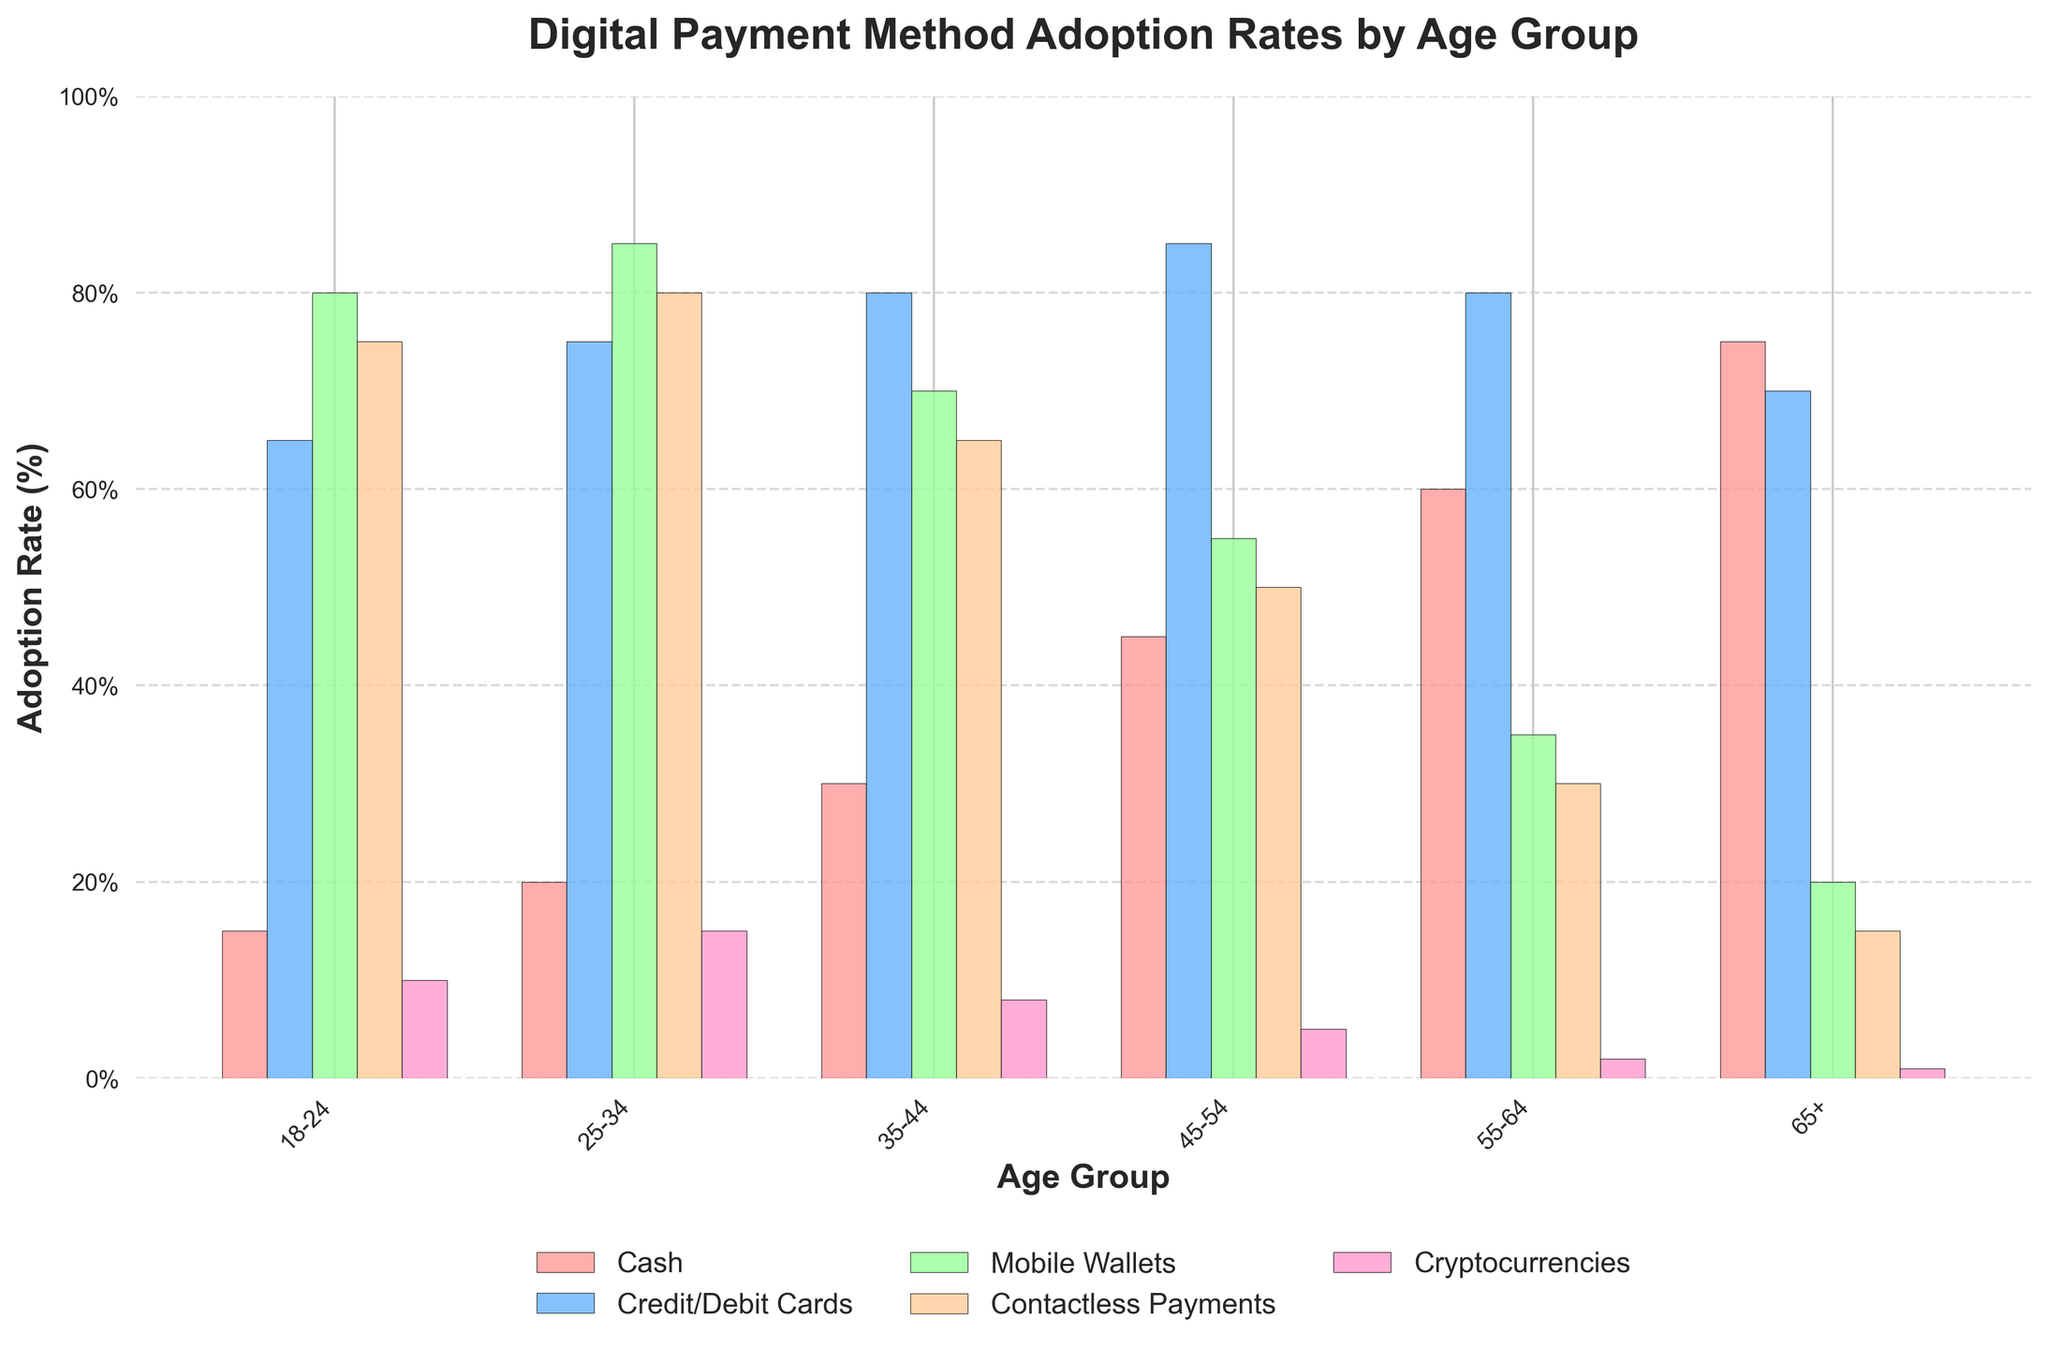What age group shows the highest adoption rate for Mobile Wallets? From the chart, look for the bar corresponding to Mobile Wallets and see which age group it reaches the highest percentage. The highest bar for Mobile Wallets is in the 25-34 age group, hitting 85%.
Answer: 25-34 Which payment method is least adopted by the 65+ age group? Identify the lowest adoption rate among the bars representing different payment methods for the 65+ age group. The lowest is Cryptocurrencies, at 1%.
Answer: Cryptocurrencies Compare the adoption rates of Contactless Payments between the 18-24 and 45-54 age groups; which one is higher and by how much? Observe the height of the bars representing Contactless Payments for the 18-24 and 45-54 age groups. The rates are 75% and 50% respectively. So, 75% - 50% = 25%. 18-24 has a 25% higher adoption rate.
Answer: 18-24 by 25% What is the average adoption rate of Credit/Debit Cards across all age groups? Add up all the percentages for Credit/Debit Cards (65%, 75%, 80%, 85%, 80%, 70%) and divide by the number of age groups, which is 6. This gives (65+75+80+85+80+70)/6 = 75.8%.
Answer: 75.8% Is the rate of Cash adoption higher for the 55-64 age group or the 18-24 age group, and by how much? Examine the heights of the bars for Cash in the age groups 55-64 and 18-24. Rates are 60% and 15% respectively. Thus, 60% - 15% = 45%. The 55-64 age group has a 45% higher cash adoption rate.
Answer: 55-64 by 45% Which age group has the lowest adoption rate of Contactless Payments, and what is the percentage? Identify the shortest bar corresponding to Contactless Payments. The 65+ group has the lowest percentage at 15%.
Answer: 65+ at 15% Sum the adoption rates of Cryptocurrencies in the 18-24 and 25-34 age groups. What is the total percentage? Add the percentages for Cryptocurrencies from the 18-24 (10%) and 25-34 (15%) age groups, resulting in 10% + 15% = 25%.
Answer: 25% For the age group 35-44, which payment method shows the second highest adoption rate and what is it? Observe the bars for different payment methods in the 35-44 age group. The highest adoption rate is for Credit/Debit Cards at 80%, and the second highest is Cash at 70%.
Answer: Cash at 70% What is the difference in the adoption rates of Mobile Wallets between the 25-34 and 45-54 age groups? Compare the bars representing Mobile Wallets in the 25-34 and 45-54 age groups. The rates are 85% and 55%, respectively. Thus, 85% - 55% equals 30%.
Answer: 30% 